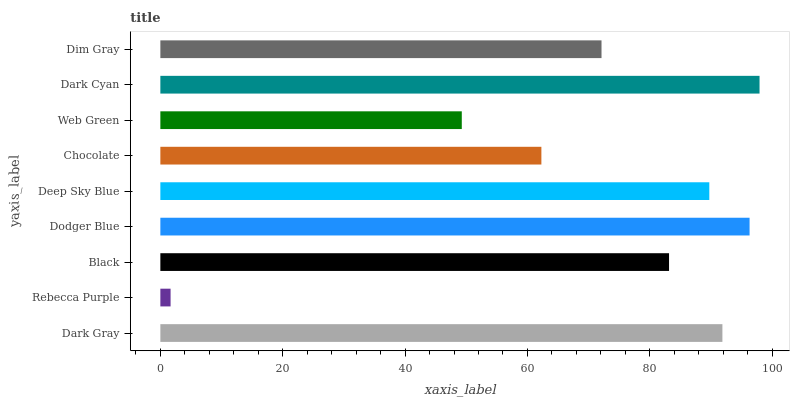Is Rebecca Purple the minimum?
Answer yes or no. Yes. Is Dark Cyan the maximum?
Answer yes or no. Yes. Is Black the minimum?
Answer yes or no. No. Is Black the maximum?
Answer yes or no. No. Is Black greater than Rebecca Purple?
Answer yes or no. Yes. Is Rebecca Purple less than Black?
Answer yes or no. Yes. Is Rebecca Purple greater than Black?
Answer yes or no. No. Is Black less than Rebecca Purple?
Answer yes or no. No. Is Black the high median?
Answer yes or no. Yes. Is Black the low median?
Answer yes or no. Yes. Is Dark Gray the high median?
Answer yes or no. No. Is Deep Sky Blue the low median?
Answer yes or no. No. 